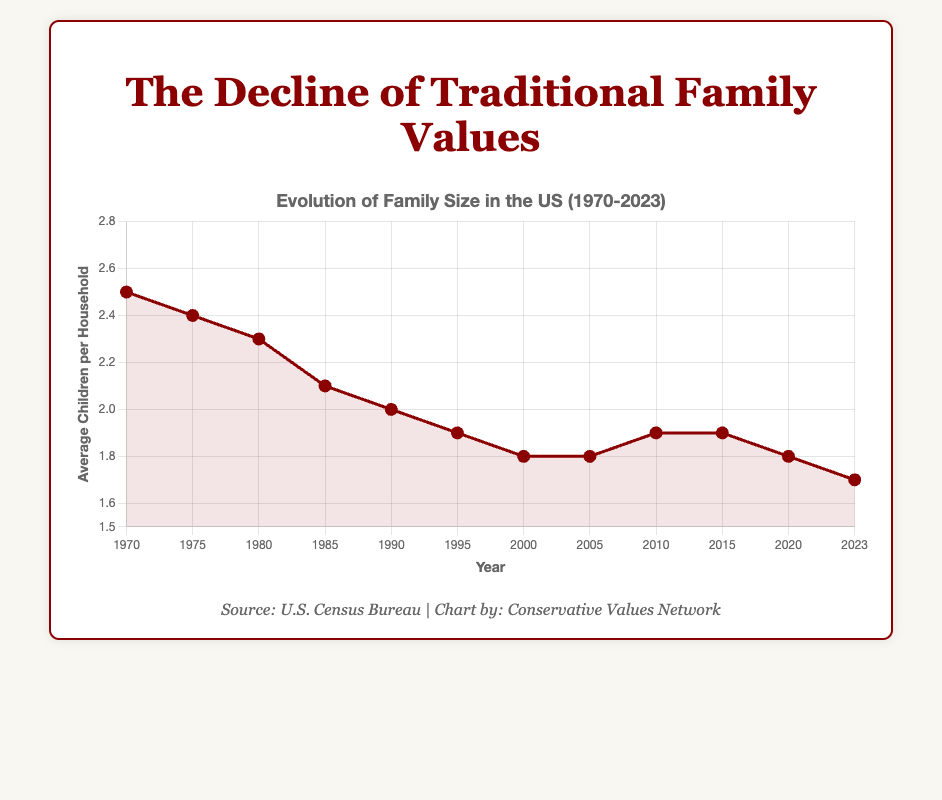What is the value of the average children per household in 1980? Look at the data point corresponding to the year 1980 on the line chart and read the value.
Answer: 2.3 What is the difference in the average children per household between 1970 and 2023? Subtract the average children per household in 2023 from that in 1970. 2.5 - 1.7 = 0.8
Answer: 0.8 In which year did the average children per household first drop below 2.0? Identify the first year in which the value drops below 2.0 by observing the trend. This happens in 1995.
Answer: 1995 From 1970 to 2023, what is the trend in the average children per household? Observe the overall direction of the line chart from 1970 to 2023. It shows a decreasing trend.
Answer: Decreasing What is the average value of children per household from 1970 to 1985? Sum the values from 1970, 1975, 1980, and 1985, then divide by the number of years. (2.5 + 2.4 + 2.3 + 2.1) / 4 = 9.3 / 4 = 2.325
Answer: 2.325 Which year experienced the smallest average children per household? Find the lowest point on the line chart throughout the entire period. 2023 has the smallest value of 1.7.
Answer: 2023 Which years had the same average children per household value? Identify the years with repeated values on the line chart. Both 2005 and 2020 have the same values at 1.8, and 2010 and 2015 both have values at 1.9.
Answer: 2005-2020, 2010-2015 How many times did the average children per household show an increase? Count the number of upward trends between consecutive years: 1 increase between 2005 and 2010.
Answer: 1 In what year did the decline in family sizes begin to stabilize around 1.8 to 1.9 children per household? Identify the period where the values remain nearly constant around 1.8 to 1.9. This stabilization begins after 2000 and continues through 2010.
Answer: 2000 What is the visual significance of the color red used for the data points? Observe that the red color is used to draw attention to the data points and the line, indicating an important trend or aspect of the data.
Answer: Highlight trend 